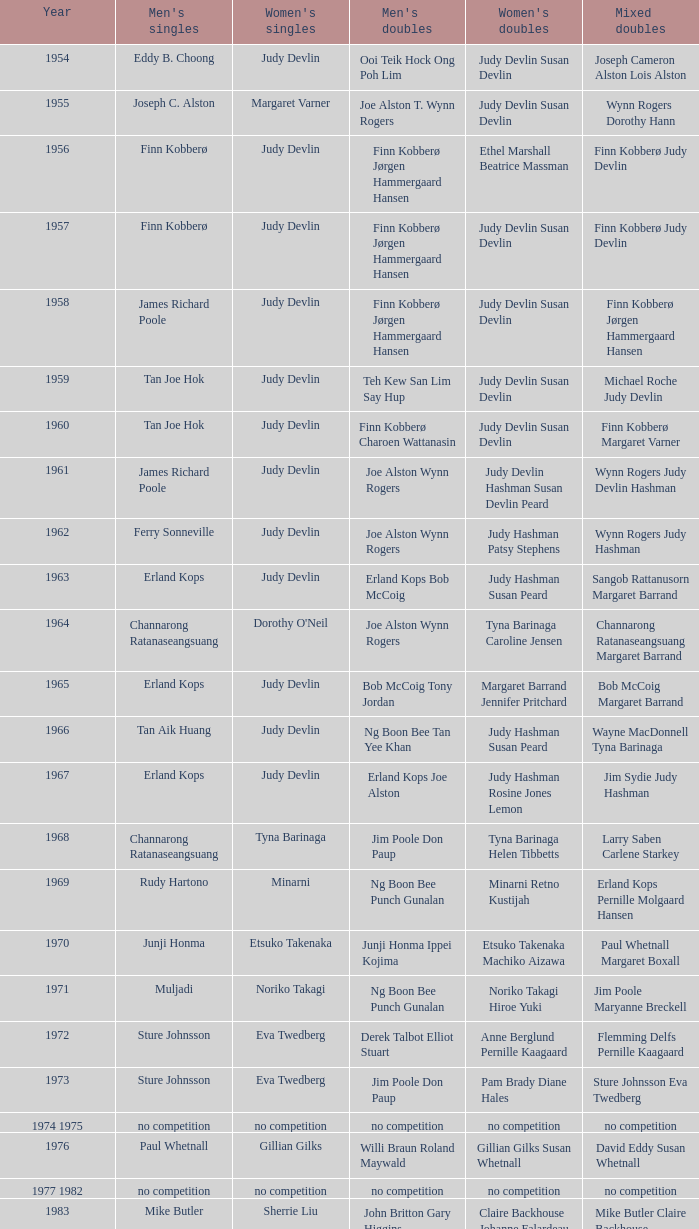Who were the men's doubles winners when the men's singles victor was muljadi? Ng Boon Bee Punch Gunalan. 